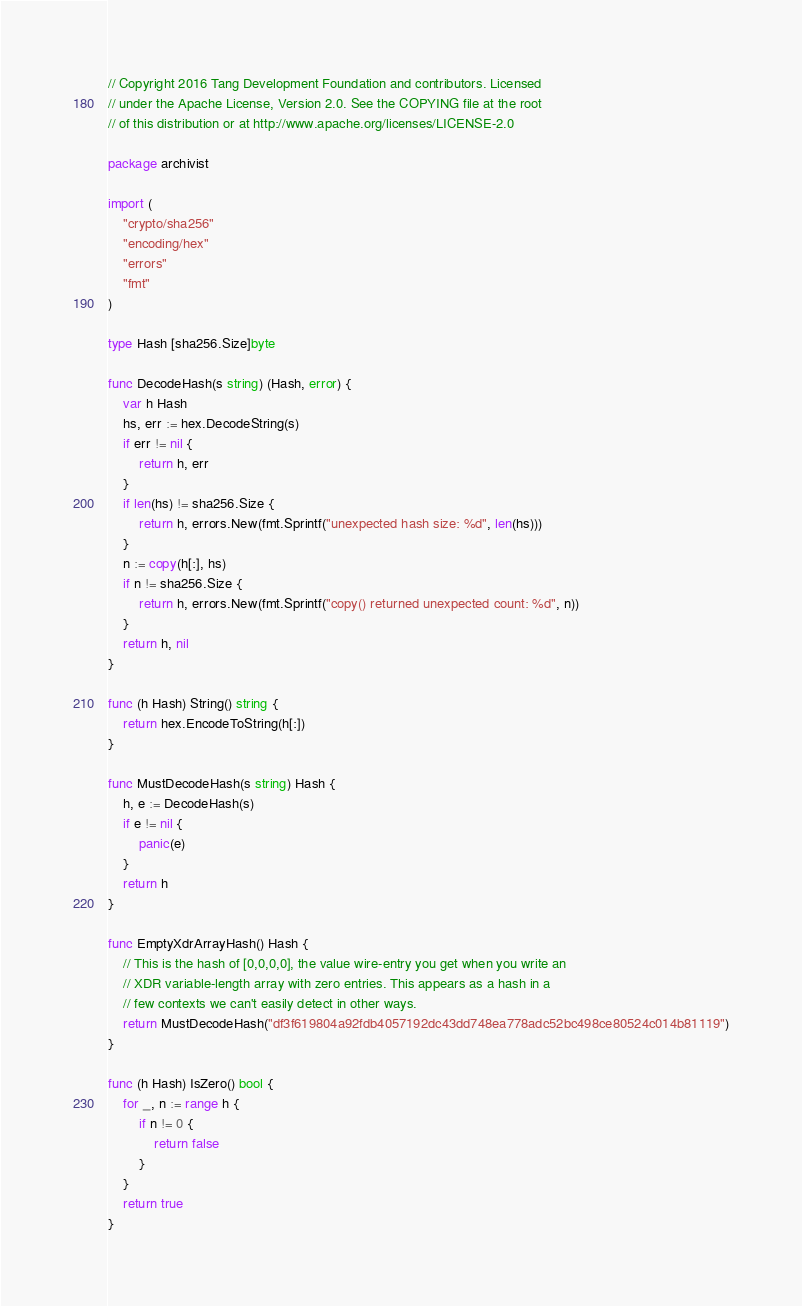Convert code to text. <code><loc_0><loc_0><loc_500><loc_500><_Go_>// Copyright 2016 Tang Development Foundation and contributors. Licensed
// under the Apache License, Version 2.0. See the COPYING file at the root
// of this distribution or at http://www.apache.org/licenses/LICENSE-2.0

package archivist

import (
	"crypto/sha256"
	"encoding/hex"
	"errors"
	"fmt"
)

type Hash [sha256.Size]byte

func DecodeHash(s string) (Hash, error) {
	var h Hash
	hs, err := hex.DecodeString(s)
	if err != nil {
		return h, err
	}
	if len(hs) != sha256.Size {
		return h, errors.New(fmt.Sprintf("unexpected hash size: %d", len(hs)))
	}
	n := copy(h[:], hs)
	if n != sha256.Size {
		return h, errors.New(fmt.Sprintf("copy() returned unexpected count: %d", n))
	}
	return h, nil
}

func (h Hash) String() string {
	return hex.EncodeToString(h[:])
}

func MustDecodeHash(s string) Hash {
	h, e := DecodeHash(s)
	if e != nil {
		panic(e)
	}
	return h
}

func EmptyXdrArrayHash() Hash {
	// This is the hash of [0,0,0,0], the value wire-entry you get when you write an
	// XDR variable-length array with zero entries. This appears as a hash in a
	// few contexts we can't easily detect in other ways.
	return MustDecodeHash("df3f619804a92fdb4057192dc43dd748ea778adc52bc498ce80524c014b81119")
}

func (h Hash) IsZero() bool {
	for _, n := range h {
		if n != 0 {
			return false
		}
	}
	return true
}
</code> 